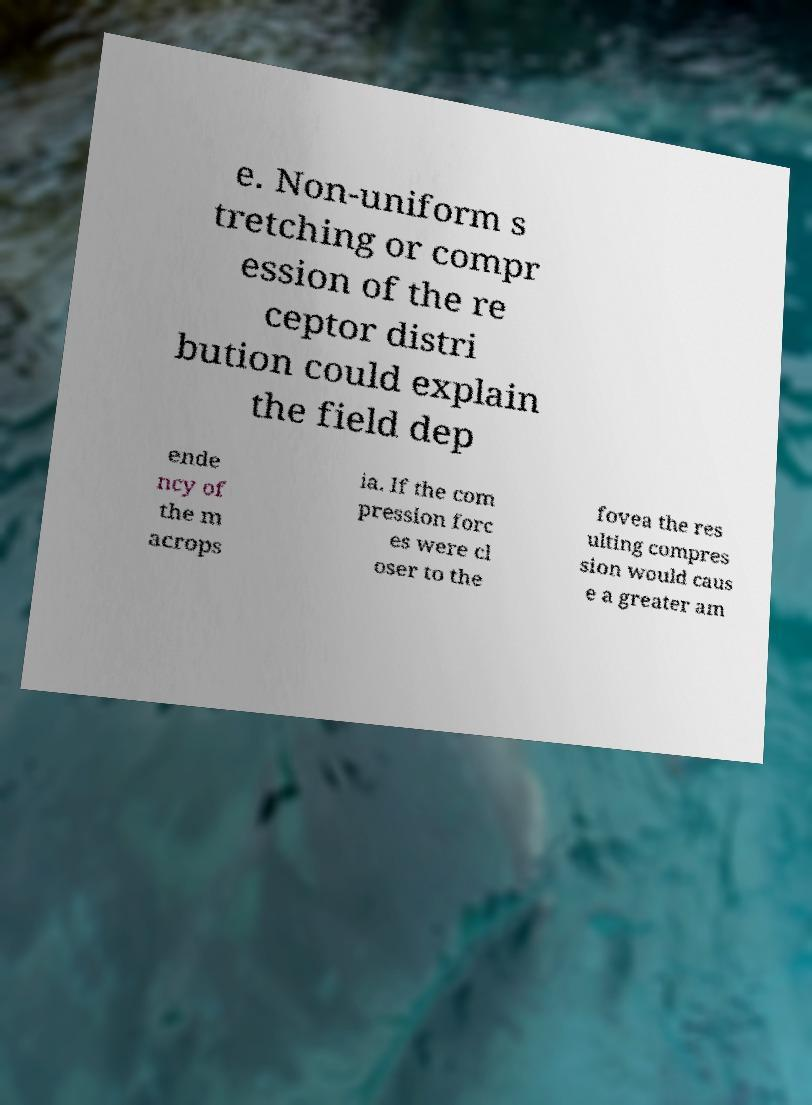Can you read and provide the text displayed in the image?This photo seems to have some interesting text. Can you extract and type it out for me? e. Non-uniform s tretching or compr ession of the re ceptor distri bution could explain the field dep ende ncy of the m acrops ia. If the com pression forc es were cl oser to the fovea the res ulting compres sion would caus e a greater am 